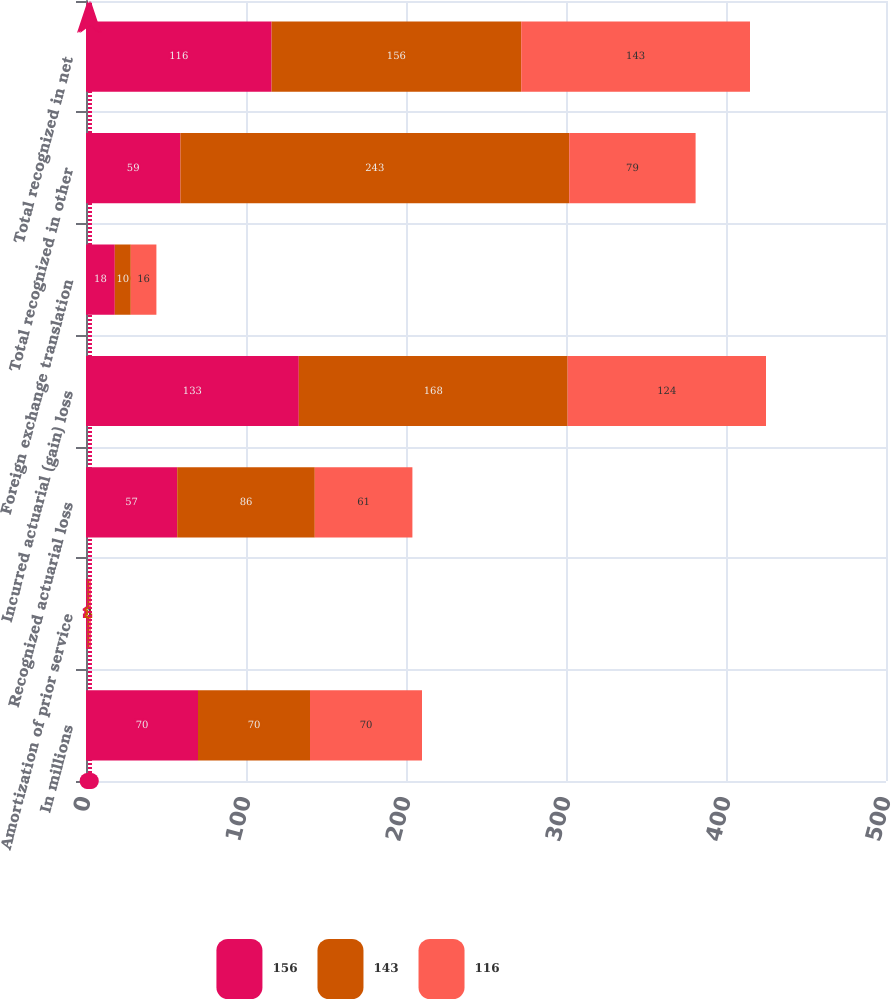<chart> <loc_0><loc_0><loc_500><loc_500><stacked_bar_chart><ecel><fcel>In millions<fcel>Amortization of prior service<fcel>Recognized actuarial loss<fcel>Incurred actuarial (gain) loss<fcel>Foreign exchange translation<fcel>Total recognized in other<fcel>Total recognized in net<nl><fcel>156<fcel>70<fcel>1<fcel>57<fcel>133<fcel>18<fcel>59<fcel>116<nl><fcel>143<fcel>70<fcel>1<fcel>86<fcel>168<fcel>10<fcel>243<fcel>156<nl><fcel>116<fcel>70<fcel>1<fcel>61<fcel>124<fcel>16<fcel>79<fcel>143<nl></chart> 